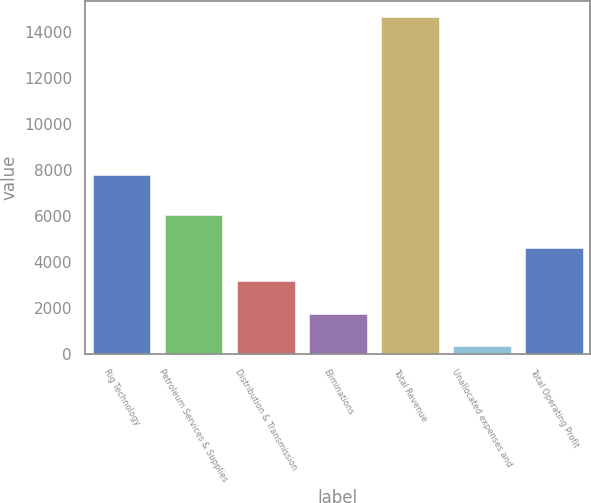Convert chart to OTSL. <chart><loc_0><loc_0><loc_500><loc_500><bar_chart><fcel>Rig Technology<fcel>Petroleum Services & Supplies<fcel>Distribution & Transmission<fcel>Eliminations<fcel>Total Revenue<fcel>Unallocated expenses and<fcel>Total Operating Profit<nl><fcel>7788<fcel>6057<fcel>3190<fcel>1756.5<fcel>14658<fcel>323<fcel>4623.5<nl></chart> 